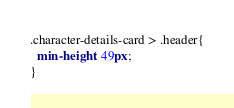<code> <loc_0><loc_0><loc_500><loc_500><_CSS_>.character-details-card > .header{
  min-height: 49px;
}</code> 